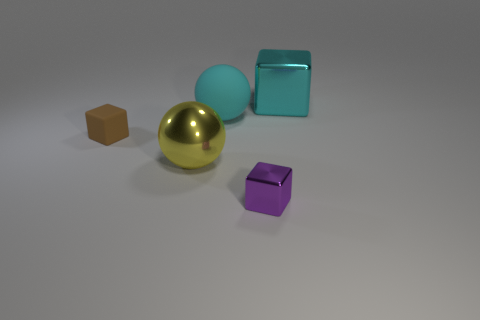What is the material of the other thing that is the same shape as the yellow object?
Provide a short and direct response. Rubber. How many objects are either metal things that are right of the purple metal cube or tiny metal cubes?
Make the answer very short. 2. There is a cyan object that is made of the same material as the brown thing; what shape is it?
Your response must be concise. Sphere. What number of rubber objects are the same shape as the big cyan metallic object?
Your answer should be very brief. 1. What is the tiny purple object made of?
Your answer should be very brief. Metal. There is a big matte sphere; is its color the same as the large metal object that is in front of the big cyan cube?
Your answer should be compact. No. What number of balls are big cyan matte things or yellow metal things?
Your answer should be compact. 2. There is a matte object in front of the big matte ball; what color is it?
Give a very brief answer. Brown. There is a metal object that is the same color as the rubber sphere; what shape is it?
Your answer should be very brief. Cube. How many yellow spheres have the same size as the cyan metallic cube?
Your response must be concise. 1. 